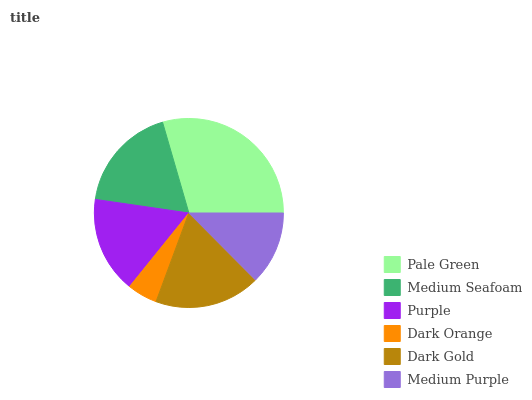Is Dark Orange the minimum?
Answer yes or no. Yes. Is Pale Green the maximum?
Answer yes or no. Yes. Is Medium Seafoam the minimum?
Answer yes or no. No. Is Medium Seafoam the maximum?
Answer yes or no. No. Is Pale Green greater than Medium Seafoam?
Answer yes or no. Yes. Is Medium Seafoam less than Pale Green?
Answer yes or no. Yes. Is Medium Seafoam greater than Pale Green?
Answer yes or no. No. Is Pale Green less than Medium Seafoam?
Answer yes or no. No. Is Dark Gold the high median?
Answer yes or no. Yes. Is Purple the low median?
Answer yes or no. Yes. Is Pale Green the high median?
Answer yes or no. No. Is Pale Green the low median?
Answer yes or no. No. 